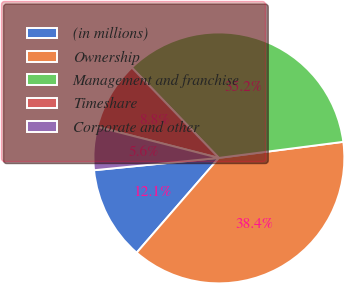<chart> <loc_0><loc_0><loc_500><loc_500><pie_chart><fcel>(in millions)<fcel>Ownership<fcel>Management and franchise<fcel>Timeshare<fcel>Corporate and other<nl><fcel>12.06%<fcel>38.42%<fcel>35.16%<fcel>8.81%<fcel>5.55%<nl></chart> 